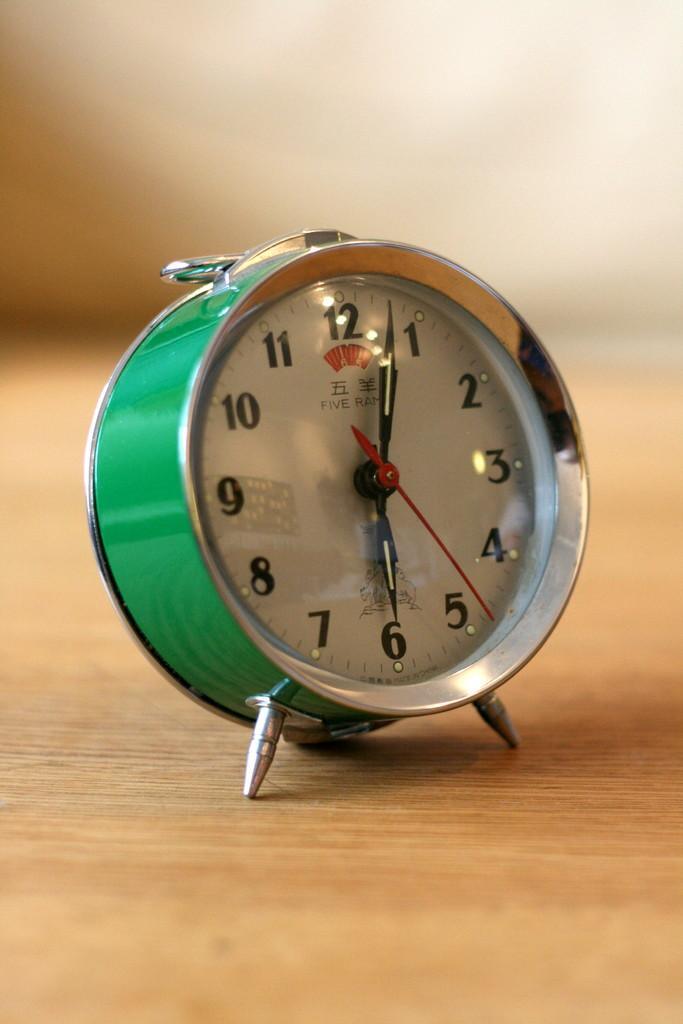Provide a one-sentence caption for the provided image. a green clock with the dials pointing at 1 and 6. 